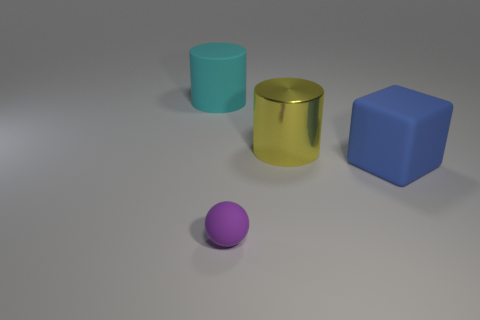Add 1 blue cylinders. How many objects exist? 5 Subtract all blocks. How many objects are left? 3 Add 1 large matte blocks. How many large matte blocks exist? 2 Subtract 1 purple balls. How many objects are left? 3 Subtract all blue matte cylinders. Subtract all yellow cylinders. How many objects are left? 3 Add 1 blue matte things. How many blue matte things are left? 2 